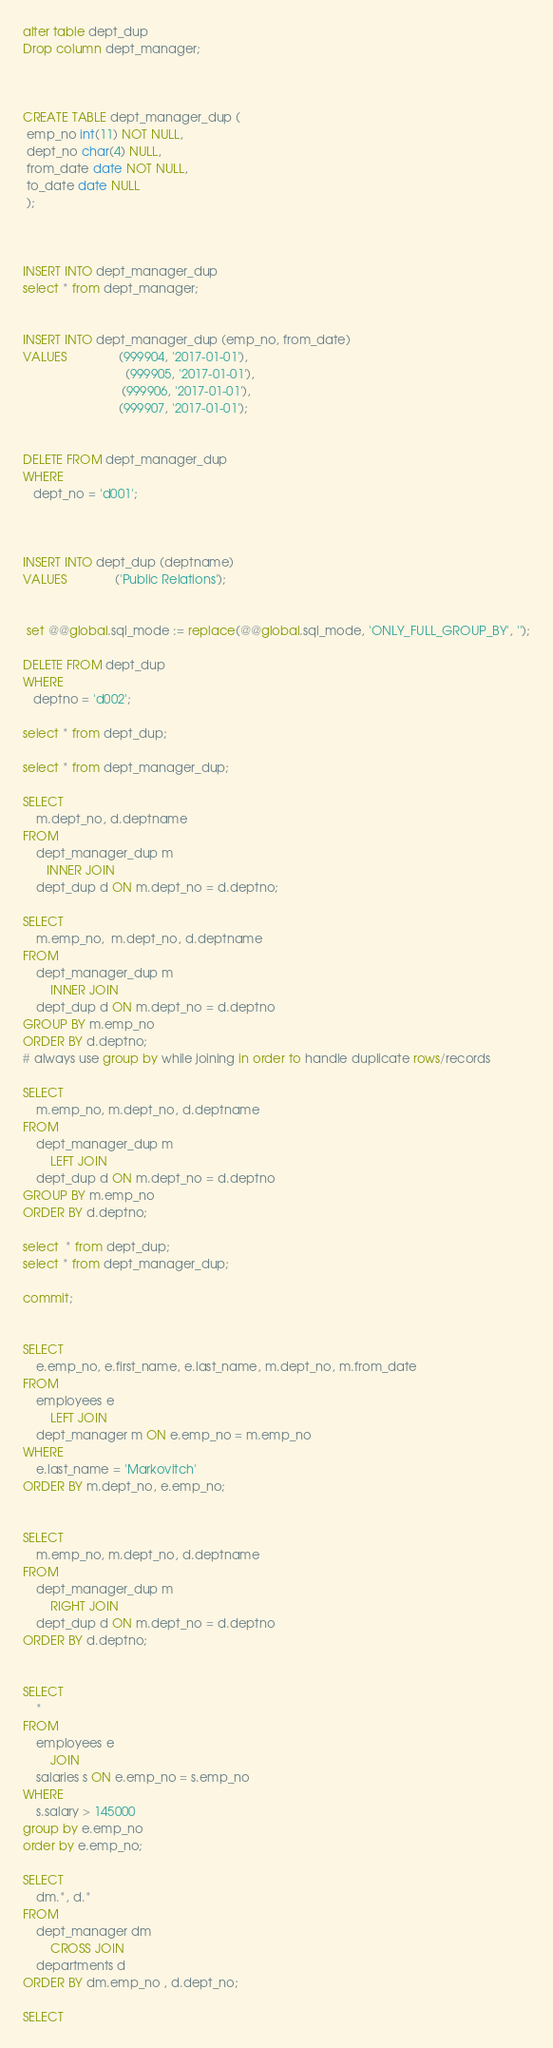Convert code to text. <code><loc_0><loc_0><loc_500><loc_500><_SQL_>alter table dept_dup
Drop column dept_manager;



CREATE TABLE dept_manager_dup (
 emp_no int(11) NOT NULL,
 dept_no char(4) NULL,
 from_date date NOT NULL,
 to_date date NULL
 );

 

INSERT INTO dept_manager_dup
select * from dept_manager;

 
INSERT INTO dept_manager_dup (emp_no, from_date)
VALUES               (999904, '2017-01-01'),
                              (999905, '2017-01-01'),
                             (999906, '2017-01-01'),
                            (999907, '2017-01-01');


DELETE FROM dept_manager_dup
WHERE
   dept_no = 'd001';

   

INSERT INTO dept_dup (deptname)
VALUES              ('Public Relations');

 
 set @@global.sql_mode := replace(@@global.sql_mode, 'ONLY_FULL_GROUP_BY', '');

DELETE FROM dept_dup
WHERE
   deptno = 'd002';
   
select * from dept_dup;

select * from dept_manager_dup;

SELECT 
    m.dept_no, d.deptname
FROM
    dept_manager_dup m
       INNER JOIN
    dept_dup d ON m.dept_no = d.deptno;
    
SELECT 
    m.emp_no,  m.dept_no, d.deptname
FROM
    dept_manager_dup m
        INNER JOIN
    dept_dup d ON m.dept_no = d.deptno
GROUP BY m.emp_no
ORDER BY d.deptno;
# always use group by while joining in order to handle duplicate rows/records

SELECT 
    m.emp_no, m.dept_no, d.deptname
FROM
    dept_manager_dup m
        LEFT JOIN
    dept_dup d ON m.dept_no = d.deptno
GROUP BY m.emp_no
ORDER BY d.deptno;

select  * from dept_dup;
select * from dept_manager_dup;

commit;


SELECT 
    e.emp_no, e.first_name, e.last_name, m.dept_no, m.from_date
FROM
    employees e
        LEFT JOIN
    dept_manager m ON e.emp_no = m.emp_no
WHERE
    e.last_name = 'Markovitch'
ORDER BY m.dept_no, e.emp_no;


SELECT 
    m.emp_no, m.dept_no, d.deptname
FROM
    dept_manager_dup m
        RIGHT JOIN
    dept_dup d ON m.dept_no = d.deptno
ORDER BY d.deptno;


SELECT 
    *
FROM
    employees e
        JOIN
    salaries s ON e.emp_no = s.emp_no
WHERE
    s.salary > 145000
group by e.emp_no
order by e.emp_no;

SELECT 
    dm.*, d.*
FROM
    dept_manager dm
        CROSS JOIN
    departments d
ORDER BY dm.emp_no , d.dept_no;

SELECT </code> 